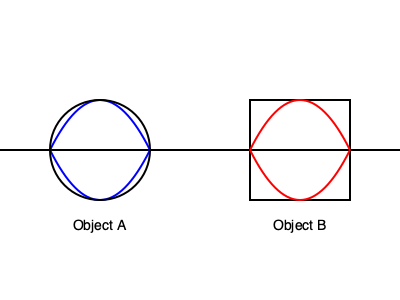Based on the airflow patterns shown around Object A (circular) and Object B (rectangular), which shape would likely be more efficient for wind turbine blade design, and why? To determine the more efficient shape for wind turbine blade design, we need to analyze the airflow patterns around both objects:

1. Object A (Circular):
   - The airflow lines are smooth and symmetrical around the object.
   - There is less turbulence and separation of flow.
   - The pressure difference between the upper and lower surfaces is relatively small.

2. Object B (Rectangular):
   - The airflow lines show sharp turns and potential separation at the corners.
   - There is more turbulence, especially at the trailing edge.
   - The pressure difference between the upper and lower surfaces is larger.

3. Efficiency considerations:
   - Wind turbine blades need to create lift to rotate efficiently.
   - Lift is generated by pressure differences between the upper and lower surfaces of the blade.
   - Turbulence and flow separation reduce efficiency and increase drag.

4. Application to wind turbine design:
   - While Object B creates a larger pressure difference, which could potentially generate more lift, it also produces more turbulence and drag.
   - Object A's smoother airflow would result in less drag and more consistent performance.
   - Modern wind turbine blades typically use airfoil shapes that combine elements of both:
     - A rounded leading edge (similar to Object A) to minimize turbulence.
     - A tapered trailing edge to create pressure differences for lift.

5. Conclusion:
   - Object A's shape is more suitable as a starting point for efficient wind turbine blade design.
   - However, optimal designs would incorporate aspects of both shapes to balance lift generation and drag reduction.
Answer: Object A (circular), due to smoother airflow and less turbulence. 